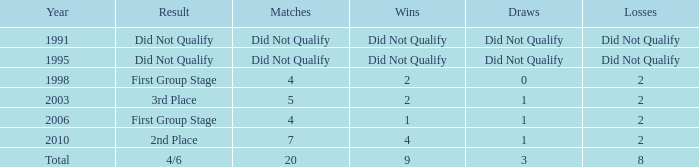How many draws were there in 2006? 1.0. 